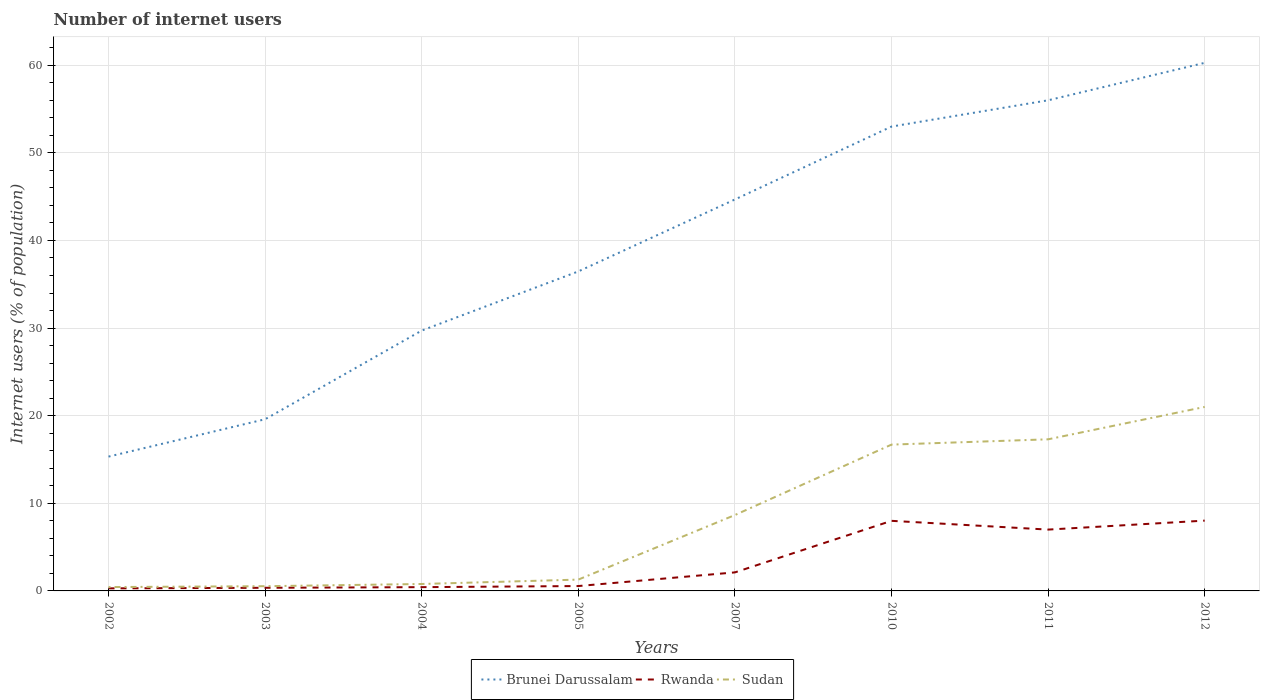How many different coloured lines are there?
Offer a terse response. 3. Does the line corresponding to Brunei Darussalam intersect with the line corresponding to Sudan?
Your response must be concise. No. Across all years, what is the maximum number of internet users in Sudan?
Provide a short and direct response. 0.44. What is the total number of internet users in Rwanda in the graph?
Your response must be concise. -7.64. What is the difference between the highest and the second highest number of internet users in Rwanda?
Provide a succinct answer. 7.73. Is the number of internet users in Brunei Darussalam strictly greater than the number of internet users in Rwanda over the years?
Provide a short and direct response. No. How many years are there in the graph?
Make the answer very short. 8. What is the difference between two consecutive major ticks on the Y-axis?
Your answer should be compact. 10. Does the graph contain any zero values?
Provide a short and direct response. No. Where does the legend appear in the graph?
Your answer should be compact. Bottom center. How many legend labels are there?
Offer a terse response. 3. How are the legend labels stacked?
Offer a very short reply. Horizontal. What is the title of the graph?
Make the answer very short. Number of internet users. What is the label or title of the X-axis?
Your answer should be compact. Years. What is the label or title of the Y-axis?
Give a very brief answer. Internet users (% of population). What is the Internet users (% of population) of Brunei Darussalam in 2002?
Make the answer very short. 15.33. What is the Internet users (% of population) of Rwanda in 2002?
Make the answer very short. 0.29. What is the Internet users (% of population) in Sudan in 2002?
Offer a very short reply. 0.44. What is the Internet users (% of population) of Brunei Darussalam in 2003?
Keep it short and to the point. 19.6. What is the Internet users (% of population) in Rwanda in 2003?
Ensure brevity in your answer.  0.36. What is the Internet users (% of population) of Sudan in 2003?
Your answer should be very brief. 0.54. What is the Internet users (% of population) in Brunei Darussalam in 2004?
Provide a succinct answer. 29.72. What is the Internet users (% of population) of Rwanda in 2004?
Make the answer very short. 0.43. What is the Internet users (% of population) in Sudan in 2004?
Give a very brief answer. 0.79. What is the Internet users (% of population) of Brunei Darussalam in 2005?
Provide a succinct answer. 36.47. What is the Internet users (% of population) of Rwanda in 2005?
Make the answer very short. 0.56. What is the Internet users (% of population) in Sudan in 2005?
Your response must be concise. 1.29. What is the Internet users (% of population) of Brunei Darussalam in 2007?
Offer a terse response. 44.68. What is the Internet users (% of population) of Rwanda in 2007?
Your response must be concise. 2.12. What is the Internet users (% of population) in Sudan in 2007?
Offer a terse response. 8.66. What is the Internet users (% of population) of Brunei Darussalam in 2010?
Keep it short and to the point. 53. What is the Internet users (% of population) in Rwanda in 2011?
Offer a very short reply. 7. What is the Internet users (% of population) of Sudan in 2011?
Provide a succinct answer. 17.3. What is the Internet users (% of population) of Brunei Darussalam in 2012?
Keep it short and to the point. 60.27. What is the Internet users (% of population) in Rwanda in 2012?
Give a very brief answer. 8.02. Across all years, what is the maximum Internet users (% of population) in Brunei Darussalam?
Provide a succinct answer. 60.27. Across all years, what is the maximum Internet users (% of population) in Rwanda?
Offer a terse response. 8.02. Across all years, what is the maximum Internet users (% of population) in Sudan?
Give a very brief answer. 21. Across all years, what is the minimum Internet users (% of population) of Brunei Darussalam?
Offer a very short reply. 15.33. Across all years, what is the minimum Internet users (% of population) of Rwanda?
Make the answer very short. 0.29. Across all years, what is the minimum Internet users (% of population) of Sudan?
Provide a succinct answer. 0.44. What is the total Internet users (% of population) of Brunei Darussalam in the graph?
Offer a very short reply. 315.06. What is the total Internet users (% of population) of Rwanda in the graph?
Your answer should be compact. 26.78. What is the total Internet users (% of population) of Sudan in the graph?
Your answer should be very brief. 66.73. What is the difference between the Internet users (% of population) of Brunei Darussalam in 2002 and that in 2003?
Keep it short and to the point. -4.27. What is the difference between the Internet users (% of population) of Rwanda in 2002 and that in 2003?
Give a very brief answer. -0.06. What is the difference between the Internet users (% of population) of Sudan in 2002 and that in 2003?
Ensure brevity in your answer.  -0.1. What is the difference between the Internet users (% of population) of Brunei Darussalam in 2002 and that in 2004?
Provide a short and direct response. -14.39. What is the difference between the Internet users (% of population) in Rwanda in 2002 and that in 2004?
Provide a short and direct response. -0.14. What is the difference between the Internet users (% of population) in Sudan in 2002 and that in 2004?
Offer a terse response. -0.35. What is the difference between the Internet users (% of population) of Brunei Darussalam in 2002 and that in 2005?
Keep it short and to the point. -21.14. What is the difference between the Internet users (% of population) of Rwanda in 2002 and that in 2005?
Provide a short and direct response. -0.26. What is the difference between the Internet users (% of population) of Sudan in 2002 and that in 2005?
Give a very brief answer. -0.85. What is the difference between the Internet users (% of population) in Brunei Darussalam in 2002 and that in 2007?
Keep it short and to the point. -29.35. What is the difference between the Internet users (% of population) in Rwanda in 2002 and that in 2007?
Offer a very short reply. -1.82. What is the difference between the Internet users (% of population) of Sudan in 2002 and that in 2007?
Make the answer very short. -8.22. What is the difference between the Internet users (% of population) of Brunei Darussalam in 2002 and that in 2010?
Offer a very short reply. -37.67. What is the difference between the Internet users (% of population) of Rwanda in 2002 and that in 2010?
Offer a very short reply. -7.71. What is the difference between the Internet users (% of population) in Sudan in 2002 and that in 2010?
Provide a short and direct response. -16.26. What is the difference between the Internet users (% of population) in Brunei Darussalam in 2002 and that in 2011?
Give a very brief answer. -40.67. What is the difference between the Internet users (% of population) in Rwanda in 2002 and that in 2011?
Your answer should be compact. -6.71. What is the difference between the Internet users (% of population) in Sudan in 2002 and that in 2011?
Make the answer very short. -16.86. What is the difference between the Internet users (% of population) of Brunei Darussalam in 2002 and that in 2012?
Provide a short and direct response. -44.94. What is the difference between the Internet users (% of population) of Rwanda in 2002 and that in 2012?
Your answer should be compact. -7.73. What is the difference between the Internet users (% of population) of Sudan in 2002 and that in 2012?
Make the answer very short. -20.56. What is the difference between the Internet users (% of population) in Brunei Darussalam in 2003 and that in 2004?
Your answer should be very brief. -10.12. What is the difference between the Internet users (% of population) in Rwanda in 2003 and that in 2004?
Keep it short and to the point. -0.07. What is the difference between the Internet users (% of population) in Sudan in 2003 and that in 2004?
Make the answer very short. -0.25. What is the difference between the Internet users (% of population) in Brunei Darussalam in 2003 and that in 2005?
Offer a terse response. -16.87. What is the difference between the Internet users (% of population) of Rwanda in 2003 and that in 2005?
Your response must be concise. -0.2. What is the difference between the Internet users (% of population) in Sudan in 2003 and that in 2005?
Make the answer very short. -0.75. What is the difference between the Internet users (% of population) of Brunei Darussalam in 2003 and that in 2007?
Give a very brief answer. -25.09. What is the difference between the Internet users (% of population) in Rwanda in 2003 and that in 2007?
Give a very brief answer. -1.76. What is the difference between the Internet users (% of population) in Sudan in 2003 and that in 2007?
Keep it short and to the point. -8.12. What is the difference between the Internet users (% of population) of Brunei Darussalam in 2003 and that in 2010?
Provide a short and direct response. -33.41. What is the difference between the Internet users (% of population) in Rwanda in 2003 and that in 2010?
Your answer should be compact. -7.64. What is the difference between the Internet users (% of population) in Sudan in 2003 and that in 2010?
Provide a short and direct response. -16.16. What is the difference between the Internet users (% of population) in Brunei Darussalam in 2003 and that in 2011?
Your response must be concise. -36.41. What is the difference between the Internet users (% of population) of Rwanda in 2003 and that in 2011?
Keep it short and to the point. -6.64. What is the difference between the Internet users (% of population) in Sudan in 2003 and that in 2011?
Ensure brevity in your answer.  -16.77. What is the difference between the Internet users (% of population) of Brunei Darussalam in 2003 and that in 2012?
Your answer should be very brief. -40.68. What is the difference between the Internet users (% of population) of Rwanda in 2003 and that in 2012?
Make the answer very short. -7.67. What is the difference between the Internet users (% of population) in Sudan in 2003 and that in 2012?
Your answer should be very brief. -20.46. What is the difference between the Internet users (% of population) of Brunei Darussalam in 2004 and that in 2005?
Offer a very short reply. -6.75. What is the difference between the Internet users (% of population) in Rwanda in 2004 and that in 2005?
Your answer should be very brief. -0.13. What is the difference between the Internet users (% of population) in Sudan in 2004 and that in 2005?
Offer a terse response. -0.5. What is the difference between the Internet users (% of population) in Brunei Darussalam in 2004 and that in 2007?
Make the answer very short. -14.96. What is the difference between the Internet users (% of population) of Rwanda in 2004 and that in 2007?
Ensure brevity in your answer.  -1.68. What is the difference between the Internet users (% of population) of Sudan in 2004 and that in 2007?
Offer a very short reply. -7.87. What is the difference between the Internet users (% of population) of Brunei Darussalam in 2004 and that in 2010?
Your answer should be compact. -23.28. What is the difference between the Internet users (% of population) in Rwanda in 2004 and that in 2010?
Provide a short and direct response. -7.57. What is the difference between the Internet users (% of population) in Sudan in 2004 and that in 2010?
Your answer should be very brief. -15.91. What is the difference between the Internet users (% of population) of Brunei Darussalam in 2004 and that in 2011?
Provide a short and direct response. -26.28. What is the difference between the Internet users (% of population) in Rwanda in 2004 and that in 2011?
Keep it short and to the point. -6.57. What is the difference between the Internet users (% of population) in Sudan in 2004 and that in 2011?
Ensure brevity in your answer.  -16.51. What is the difference between the Internet users (% of population) of Brunei Darussalam in 2004 and that in 2012?
Make the answer very short. -30.56. What is the difference between the Internet users (% of population) in Rwanda in 2004 and that in 2012?
Make the answer very short. -7.59. What is the difference between the Internet users (% of population) of Sudan in 2004 and that in 2012?
Provide a succinct answer. -20.21. What is the difference between the Internet users (% of population) of Brunei Darussalam in 2005 and that in 2007?
Offer a very short reply. -8.21. What is the difference between the Internet users (% of population) of Rwanda in 2005 and that in 2007?
Keep it short and to the point. -1.56. What is the difference between the Internet users (% of population) in Sudan in 2005 and that in 2007?
Your answer should be compact. -7.37. What is the difference between the Internet users (% of population) of Brunei Darussalam in 2005 and that in 2010?
Offer a very short reply. -16.53. What is the difference between the Internet users (% of population) of Rwanda in 2005 and that in 2010?
Ensure brevity in your answer.  -7.44. What is the difference between the Internet users (% of population) in Sudan in 2005 and that in 2010?
Your answer should be compact. -15.41. What is the difference between the Internet users (% of population) of Brunei Darussalam in 2005 and that in 2011?
Offer a terse response. -19.53. What is the difference between the Internet users (% of population) in Rwanda in 2005 and that in 2011?
Offer a terse response. -6.44. What is the difference between the Internet users (% of population) in Sudan in 2005 and that in 2011?
Your answer should be compact. -16.01. What is the difference between the Internet users (% of population) of Brunei Darussalam in 2005 and that in 2012?
Make the answer very short. -23.81. What is the difference between the Internet users (% of population) in Rwanda in 2005 and that in 2012?
Provide a short and direct response. -7.47. What is the difference between the Internet users (% of population) in Sudan in 2005 and that in 2012?
Ensure brevity in your answer.  -19.71. What is the difference between the Internet users (% of population) in Brunei Darussalam in 2007 and that in 2010?
Offer a terse response. -8.32. What is the difference between the Internet users (% of population) in Rwanda in 2007 and that in 2010?
Provide a succinct answer. -5.88. What is the difference between the Internet users (% of population) in Sudan in 2007 and that in 2010?
Give a very brief answer. -8.04. What is the difference between the Internet users (% of population) of Brunei Darussalam in 2007 and that in 2011?
Your response must be concise. -11.32. What is the difference between the Internet users (% of population) in Rwanda in 2007 and that in 2011?
Keep it short and to the point. -4.88. What is the difference between the Internet users (% of population) of Sudan in 2007 and that in 2011?
Your response must be concise. -8.64. What is the difference between the Internet users (% of population) in Brunei Darussalam in 2007 and that in 2012?
Keep it short and to the point. -15.59. What is the difference between the Internet users (% of population) in Rwanda in 2007 and that in 2012?
Your answer should be compact. -5.91. What is the difference between the Internet users (% of population) of Sudan in 2007 and that in 2012?
Ensure brevity in your answer.  -12.34. What is the difference between the Internet users (% of population) in Brunei Darussalam in 2010 and that in 2011?
Provide a succinct answer. -3. What is the difference between the Internet users (% of population) in Rwanda in 2010 and that in 2011?
Offer a very short reply. 1. What is the difference between the Internet users (% of population) in Sudan in 2010 and that in 2011?
Offer a very short reply. -0.6. What is the difference between the Internet users (% of population) in Brunei Darussalam in 2010 and that in 2012?
Offer a very short reply. -7.27. What is the difference between the Internet users (% of population) in Rwanda in 2010 and that in 2012?
Offer a terse response. -0.02. What is the difference between the Internet users (% of population) of Sudan in 2010 and that in 2012?
Give a very brief answer. -4.3. What is the difference between the Internet users (% of population) in Brunei Darussalam in 2011 and that in 2012?
Your answer should be compact. -4.27. What is the difference between the Internet users (% of population) of Rwanda in 2011 and that in 2012?
Provide a succinct answer. -1.02. What is the difference between the Internet users (% of population) in Sudan in 2011 and that in 2012?
Give a very brief answer. -3.7. What is the difference between the Internet users (% of population) in Brunei Darussalam in 2002 and the Internet users (% of population) in Rwanda in 2003?
Keep it short and to the point. 14.97. What is the difference between the Internet users (% of population) in Brunei Darussalam in 2002 and the Internet users (% of population) in Sudan in 2003?
Offer a terse response. 14.79. What is the difference between the Internet users (% of population) of Rwanda in 2002 and the Internet users (% of population) of Sudan in 2003?
Offer a terse response. -0.25. What is the difference between the Internet users (% of population) of Brunei Darussalam in 2002 and the Internet users (% of population) of Rwanda in 2004?
Provide a short and direct response. 14.9. What is the difference between the Internet users (% of population) in Brunei Darussalam in 2002 and the Internet users (% of population) in Sudan in 2004?
Your answer should be very brief. 14.54. What is the difference between the Internet users (% of population) of Rwanda in 2002 and the Internet users (% of population) of Sudan in 2004?
Ensure brevity in your answer.  -0.5. What is the difference between the Internet users (% of population) in Brunei Darussalam in 2002 and the Internet users (% of population) in Rwanda in 2005?
Offer a very short reply. 14.77. What is the difference between the Internet users (% of population) of Brunei Darussalam in 2002 and the Internet users (% of population) of Sudan in 2005?
Make the answer very short. 14.04. What is the difference between the Internet users (% of population) of Rwanda in 2002 and the Internet users (% of population) of Sudan in 2005?
Offer a terse response. -1. What is the difference between the Internet users (% of population) of Brunei Darussalam in 2002 and the Internet users (% of population) of Rwanda in 2007?
Provide a succinct answer. 13.21. What is the difference between the Internet users (% of population) in Brunei Darussalam in 2002 and the Internet users (% of population) in Sudan in 2007?
Offer a terse response. 6.67. What is the difference between the Internet users (% of population) in Rwanda in 2002 and the Internet users (% of population) in Sudan in 2007?
Your response must be concise. -8.37. What is the difference between the Internet users (% of population) in Brunei Darussalam in 2002 and the Internet users (% of population) in Rwanda in 2010?
Make the answer very short. 7.33. What is the difference between the Internet users (% of population) of Brunei Darussalam in 2002 and the Internet users (% of population) of Sudan in 2010?
Your response must be concise. -1.37. What is the difference between the Internet users (% of population) of Rwanda in 2002 and the Internet users (% of population) of Sudan in 2010?
Offer a very short reply. -16.41. What is the difference between the Internet users (% of population) in Brunei Darussalam in 2002 and the Internet users (% of population) in Rwanda in 2011?
Give a very brief answer. 8.33. What is the difference between the Internet users (% of population) in Brunei Darussalam in 2002 and the Internet users (% of population) in Sudan in 2011?
Provide a short and direct response. -1.97. What is the difference between the Internet users (% of population) of Rwanda in 2002 and the Internet users (% of population) of Sudan in 2011?
Offer a very short reply. -17.01. What is the difference between the Internet users (% of population) of Brunei Darussalam in 2002 and the Internet users (% of population) of Rwanda in 2012?
Give a very brief answer. 7.31. What is the difference between the Internet users (% of population) in Brunei Darussalam in 2002 and the Internet users (% of population) in Sudan in 2012?
Ensure brevity in your answer.  -5.67. What is the difference between the Internet users (% of population) of Rwanda in 2002 and the Internet users (% of population) of Sudan in 2012?
Your response must be concise. -20.71. What is the difference between the Internet users (% of population) in Brunei Darussalam in 2003 and the Internet users (% of population) in Rwanda in 2004?
Your response must be concise. 19.16. What is the difference between the Internet users (% of population) in Brunei Darussalam in 2003 and the Internet users (% of population) in Sudan in 2004?
Ensure brevity in your answer.  18.8. What is the difference between the Internet users (% of population) of Rwanda in 2003 and the Internet users (% of population) of Sudan in 2004?
Your answer should be compact. -0.43. What is the difference between the Internet users (% of population) in Brunei Darussalam in 2003 and the Internet users (% of population) in Rwanda in 2005?
Provide a succinct answer. 19.04. What is the difference between the Internet users (% of population) of Brunei Darussalam in 2003 and the Internet users (% of population) of Sudan in 2005?
Your response must be concise. 18.3. What is the difference between the Internet users (% of population) of Rwanda in 2003 and the Internet users (% of population) of Sudan in 2005?
Provide a short and direct response. -0.94. What is the difference between the Internet users (% of population) in Brunei Darussalam in 2003 and the Internet users (% of population) in Rwanda in 2007?
Your response must be concise. 17.48. What is the difference between the Internet users (% of population) of Brunei Darussalam in 2003 and the Internet users (% of population) of Sudan in 2007?
Your response must be concise. 10.94. What is the difference between the Internet users (% of population) in Rwanda in 2003 and the Internet users (% of population) in Sudan in 2007?
Keep it short and to the point. -8.3. What is the difference between the Internet users (% of population) of Brunei Darussalam in 2003 and the Internet users (% of population) of Rwanda in 2010?
Ensure brevity in your answer.  11.6. What is the difference between the Internet users (% of population) of Brunei Darussalam in 2003 and the Internet users (% of population) of Sudan in 2010?
Make the answer very short. 2.9. What is the difference between the Internet users (% of population) in Rwanda in 2003 and the Internet users (% of population) in Sudan in 2010?
Your answer should be compact. -16.34. What is the difference between the Internet users (% of population) of Brunei Darussalam in 2003 and the Internet users (% of population) of Rwanda in 2011?
Keep it short and to the point. 12.6. What is the difference between the Internet users (% of population) in Brunei Darussalam in 2003 and the Internet users (% of population) in Sudan in 2011?
Make the answer very short. 2.29. What is the difference between the Internet users (% of population) of Rwanda in 2003 and the Internet users (% of population) of Sudan in 2011?
Make the answer very short. -16.95. What is the difference between the Internet users (% of population) of Brunei Darussalam in 2003 and the Internet users (% of population) of Rwanda in 2012?
Offer a terse response. 11.57. What is the difference between the Internet users (% of population) in Brunei Darussalam in 2003 and the Internet users (% of population) in Sudan in 2012?
Provide a short and direct response. -1.41. What is the difference between the Internet users (% of population) of Rwanda in 2003 and the Internet users (% of population) of Sudan in 2012?
Give a very brief answer. -20.64. What is the difference between the Internet users (% of population) of Brunei Darussalam in 2004 and the Internet users (% of population) of Rwanda in 2005?
Your answer should be compact. 29.16. What is the difference between the Internet users (% of population) of Brunei Darussalam in 2004 and the Internet users (% of population) of Sudan in 2005?
Provide a succinct answer. 28.42. What is the difference between the Internet users (% of population) in Rwanda in 2004 and the Internet users (% of population) in Sudan in 2005?
Offer a terse response. -0.86. What is the difference between the Internet users (% of population) of Brunei Darussalam in 2004 and the Internet users (% of population) of Rwanda in 2007?
Provide a succinct answer. 27.6. What is the difference between the Internet users (% of population) of Brunei Darussalam in 2004 and the Internet users (% of population) of Sudan in 2007?
Your answer should be very brief. 21.06. What is the difference between the Internet users (% of population) of Rwanda in 2004 and the Internet users (% of population) of Sudan in 2007?
Offer a terse response. -8.23. What is the difference between the Internet users (% of population) in Brunei Darussalam in 2004 and the Internet users (% of population) in Rwanda in 2010?
Ensure brevity in your answer.  21.72. What is the difference between the Internet users (% of population) in Brunei Darussalam in 2004 and the Internet users (% of population) in Sudan in 2010?
Offer a terse response. 13.02. What is the difference between the Internet users (% of population) in Rwanda in 2004 and the Internet users (% of population) in Sudan in 2010?
Your response must be concise. -16.27. What is the difference between the Internet users (% of population) in Brunei Darussalam in 2004 and the Internet users (% of population) in Rwanda in 2011?
Offer a terse response. 22.72. What is the difference between the Internet users (% of population) of Brunei Darussalam in 2004 and the Internet users (% of population) of Sudan in 2011?
Keep it short and to the point. 12.41. What is the difference between the Internet users (% of population) of Rwanda in 2004 and the Internet users (% of population) of Sudan in 2011?
Your answer should be compact. -16.87. What is the difference between the Internet users (% of population) of Brunei Darussalam in 2004 and the Internet users (% of population) of Rwanda in 2012?
Offer a very short reply. 21.69. What is the difference between the Internet users (% of population) in Brunei Darussalam in 2004 and the Internet users (% of population) in Sudan in 2012?
Offer a terse response. 8.72. What is the difference between the Internet users (% of population) in Rwanda in 2004 and the Internet users (% of population) in Sudan in 2012?
Ensure brevity in your answer.  -20.57. What is the difference between the Internet users (% of population) in Brunei Darussalam in 2005 and the Internet users (% of population) in Rwanda in 2007?
Your answer should be very brief. 34.35. What is the difference between the Internet users (% of population) in Brunei Darussalam in 2005 and the Internet users (% of population) in Sudan in 2007?
Keep it short and to the point. 27.81. What is the difference between the Internet users (% of population) of Rwanda in 2005 and the Internet users (% of population) of Sudan in 2007?
Your answer should be compact. -8.1. What is the difference between the Internet users (% of population) of Brunei Darussalam in 2005 and the Internet users (% of population) of Rwanda in 2010?
Provide a short and direct response. 28.47. What is the difference between the Internet users (% of population) in Brunei Darussalam in 2005 and the Internet users (% of population) in Sudan in 2010?
Provide a succinct answer. 19.77. What is the difference between the Internet users (% of population) of Rwanda in 2005 and the Internet users (% of population) of Sudan in 2010?
Keep it short and to the point. -16.14. What is the difference between the Internet users (% of population) in Brunei Darussalam in 2005 and the Internet users (% of population) in Rwanda in 2011?
Give a very brief answer. 29.47. What is the difference between the Internet users (% of population) in Brunei Darussalam in 2005 and the Internet users (% of population) in Sudan in 2011?
Offer a terse response. 19.16. What is the difference between the Internet users (% of population) in Rwanda in 2005 and the Internet users (% of population) in Sudan in 2011?
Your response must be concise. -16.75. What is the difference between the Internet users (% of population) of Brunei Darussalam in 2005 and the Internet users (% of population) of Rwanda in 2012?
Give a very brief answer. 28.44. What is the difference between the Internet users (% of population) in Brunei Darussalam in 2005 and the Internet users (% of population) in Sudan in 2012?
Make the answer very short. 15.47. What is the difference between the Internet users (% of population) of Rwanda in 2005 and the Internet users (% of population) of Sudan in 2012?
Provide a short and direct response. -20.44. What is the difference between the Internet users (% of population) in Brunei Darussalam in 2007 and the Internet users (% of population) in Rwanda in 2010?
Your response must be concise. 36.68. What is the difference between the Internet users (% of population) of Brunei Darussalam in 2007 and the Internet users (% of population) of Sudan in 2010?
Give a very brief answer. 27.98. What is the difference between the Internet users (% of population) in Rwanda in 2007 and the Internet users (% of population) in Sudan in 2010?
Ensure brevity in your answer.  -14.58. What is the difference between the Internet users (% of population) of Brunei Darussalam in 2007 and the Internet users (% of population) of Rwanda in 2011?
Provide a succinct answer. 37.68. What is the difference between the Internet users (% of population) of Brunei Darussalam in 2007 and the Internet users (% of population) of Sudan in 2011?
Offer a very short reply. 27.38. What is the difference between the Internet users (% of population) of Rwanda in 2007 and the Internet users (% of population) of Sudan in 2011?
Provide a short and direct response. -15.19. What is the difference between the Internet users (% of population) in Brunei Darussalam in 2007 and the Internet users (% of population) in Rwanda in 2012?
Your answer should be compact. 36.66. What is the difference between the Internet users (% of population) in Brunei Darussalam in 2007 and the Internet users (% of population) in Sudan in 2012?
Provide a succinct answer. 23.68. What is the difference between the Internet users (% of population) in Rwanda in 2007 and the Internet users (% of population) in Sudan in 2012?
Your answer should be very brief. -18.88. What is the difference between the Internet users (% of population) in Brunei Darussalam in 2010 and the Internet users (% of population) in Sudan in 2011?
Make the answer very short. 35.7. What is the difference between the Internet users (% of population) in Rwanda in 2010 and the Internet users (% of population) in Sudan in 2011?
Keep it short and to the point. -9.3. What is the difference between the Internet users (% of population) in Brunei Darussalam in 2010 and the Internet users (% of population) in Rwanda in 2012?
Give a very brief answer. 44.98. What is the difference between the Internet users (% of population) in Rwanda in 2010 and the Internet users (% of population) in Sudan in 2012?
Your response must be concise. -13. What is the difference between the Internet users (% of population) in Brunei Darussalam in 2011 and the Internet users (% of population) in Rwanda in 2012?
Your response must be concise. 47.98. What is the difference between the Internet users (% of population) in Brunei Darussalam in 2011 and the Internet users (% of population) in Sudan in 2012?
Provide a short and direct response. 35. What is the difference between the Internet users (% of population) of Rwanda in 2011 and the Internet users (% of population) of Sudan in 2012?
Keep it short and to the point. -14. What is the average Internet users (% of population) in Brunei Darussalam per year?
Offer a terse response. 39.38. What is the average Internet users (% of population) in Rwanda per year?
Your answer should be very brief. 3.35. What is the average Internet users (% of population) of Sudan per year?
Your answer should be compact. 8.34. In the year 2002, what is the difference between the Internet users (% of population) in Brunei Darussalam and Internet users (% of population) in Rwanda?
Offer a very short reply. 15.04. In the year 2002, what is the difference between the Internet users (% of population) of Brunei Darussalam and Internet users (% of population) of Sudan?
Your answer should be compact. 14.89. In the year 2002, what is the difference between the Internet users (% of population) of Rwanda and Internet users (% of population) of Sudan?
Ensure brevity in your answer.  -0.15. In the year 2003, what is the difference between the Internet users (% of population) in Brunei Darussalam and Internet users (% of population) in Rwanda?
Give a very brief answer. 19.24. In the year 2003, what is the difference between the Internet users (% of population) of Brunei Darussalam and Internet users (% of population) of Sudan?
Give a very brief answer. 19.06. In the year 2003, what is the difference between the Internet users (% of population) in Rwanda and Internet users (% of population) in Sudan?
Your answer should be compact. -0.18. In the year 2004, what is the difference between the Internet users (% of population) in Brunei Darussalam and Internet users (% of population) in Rwanda?
Give a very brief answer. 29.28. In the year 2004, what is the difference between the Internet users (% of population) of Brunei Darussalam and Internet users (% of population) of Sudan?
Offer a terse response. 28.92. In the year 2004, what is the difference between the Internet users (% of population) of Rwanda and Internet users (% of population) of Sudan?
Provide a short and direct response. -0.36. In the year 2005, what is the difference between the Internet users (% of population) in Brunei Darussalam and Internet users (% of population) in Rwanda?
Provide a short and direct response. 35.91. In the year 2005, what is the difference between the Internet users (% of population) in Brunei Darussalam and Internet users (% of population) in Sudan?
Offer a very short reply. 35.17. In the year 2005, what is the difference between the Internet users (% of population) of Rwanda and Internet users (% of population) of Sudan?
Provide a short and direct response. -0.74. In the year 2007, what is the difference between the Internet users (% of population) of Brunei Darussalam and Internet users (% of population) of Rwanda?
Your answer should be very brief. 42.56. In the year 2007, what is the difference between the Internet users (% of population) in Brunei Darussalam and Internet users (% of population) in Sudan?
Your response must be concise. 36.02. In the year 2007, what is the difference between the Internet users (% of population) in Rwanda and Internet users (% of population) in Sudan?
Keep it short and to the point. -6.54. In the year 2010, what is the difference between the Internet users (% of population) in Brunei Darussalam and Internet users (% of population) in Rwanda?
Your answer should be very brief. 45. In the year 2010, what is the difference between the Internet users (% of population) of Brunei Darussalam and Internet users (% of population) of Sudan?
Make the answer very short. 36.3. In the year 2011, what is the difference between the Internet users (% of population) of Brunei Darussalam and Internet users (% of population) of Sudan?
Your answer should be compact. 38.7. In the year 2011, what is the difference between the Internet users (% of population) in Rwanda and Internet users (% of population) in Sudan?
Your answer should be compact. -10.3. In the year 2012, what is the difference between the Internet users (% of population) of Brunei Darussalam and Internet users (% of population) of Rwanda?
Offer a terse response. 52.25. In the year 2012, what is the difference between the Internet users (% of population) in Brunei Darussalam and Internet users (% of population) in Sudan?
Your answer should be very brief. 39.27. In the year 2012, what is the difference between the Internet users (% of population) in Rwanda and Internet users (% of population) in Sudan?
Give a very brief answer. -12.98. What is the ratio of the Internet users (% of population) of Brunei Darussalam in 2002 to that in 2003?
Provide a succinct answer. 0.78. What is the ratio of the Internet users (% of population) of Rwanda in 2002 to that in 2003?
Your response must be concise. 0.82. What is the ratio of the Internet users (% of population) in Sudan in 2002 to that in 2003?
Your answer should be compact. 0.82. What is the ratio of the Internet users (% of population) of Brunei Darussalam in 2002 to that in 2004?
Provide a succinct answer. 0.52. What is the ratio of the Internet users (% of population) of Rwanda in 2002 to that in 2004?
Provide a succinct answer. 0.68. What is the ratio of the Internet users (% of population) of Sudan in 2002 to that in 2004?
Ensure brevity in your answer.  0.56. What is the ratio of the Internet users (% of population) of Brunei Darussalam in 2002 to that in 2005?
Make the answer very short. 0.42. What is the ratio of the Internet users (% of population) of Rwanda in 2002 to that in 2005?
Offer a terse response. 0.53. What is the ratio of the Internet users (% of population) of Sudan in 2002 to that in 2005?
Offer a very short reply. 0.34. What is the ratio of the Internet users (% of population) of Brunei Darussalam in 2002 to that in 2007?
Offer a very short reply. 0.34. What is the ratio of the Internet users (% of population) in Rwanda in 2002 to that in 2007?
Provide a short and direct response. 0.14. What is the ratio of the Internet users (% of population) in Sudan in 2002 to that in 2007?
Your answer should be very brief. 0.05. What is the ratio of the Internet users (% of population) of Brunei Darussalam in 2002 to that in 2010?
Provide a short and direct response. 0.29. What is the ratio of the Internet users (% of population) of Rwanda in 2002 to that in 2010?
Your answer should be very brief. 0.04. What is the ratio of the Internet users (% of population) of Sudan in 2002 to that in 2010?
Offer a terse response. 0.03. What is the ratio of the Internet users (% of population) of Brunei Darussalam in 2002 to that in 2011?
Your answer should be compact. 0.27. What is the ratio of the Internet users (% of population) in Rwanda in 2002 to that in 2011?
Keep it short and to the point. 0.04. What is the ratio of the Internet users (% of population) in Sudan in 2002 to that in 2011?
Offer a terse response. 0.03. What is the ratio of the Internet users (% of population) in Brunei Darussalam in 2002 to that in 2012?
Your response must be concise. 0.25. What is the ratio of the Internet users (% of population) in Rwanda in 2002 to that in 2012?
Make the answer very short. 0.04. What is the ratio of the Internet users (% of population) of Sudan in 2002 to that in 2012?
Your answer should be compact. 0.02. What is the ratio of the Internet users (% of population) of Brunei Darussalam in 2003 to that in 2004?
Make the answer very short. 0.66. What is the ratio of the Internet users (% of population) in Rwanda in 2003 to that in 2004?
Your response must be concise. 0.83. What is the ratio of the Internet users (% of population) in Sudan in 2003 to that in 2004?
Offer a very short reply. 0.68. What is the ratio of the Internet users (% of population) in Brunei Darussalam in 2003 to that in 2005?
Provide a succinct answer. 0.54. What is the ratio of the Internet users (% of population) of Rwanda in 2003 to that in 2005?
Keep it short and to the point. 0.64. What is the ratio of the Internet users (% of population) of Sudan in 2003 to that in 2005?
Provide a succinct answer. 0.42. What is the ratio of the Internet users (% of population) of Brunei Darussalam in 2003 to that in 2007?
Provide a succinct answer. 0.44. What is the ratio of the Internet users (% of population) in Rwanda in 2003 to that in 2007?
Provide a short and direct response. 0.17. What is the ratio of the Internet users (% of population) of Sudan in 2003 to that in 2007?
Make the answer very short. 0.06. What is the ratio of the Internet users (% of population) of Brunei Darussalam in 2003 to that in 2010?
Keep it short and to the point. 0.37. What is the ratio of the Internet users (% of population) in Rwanda in 2003 to that in 2010?
Your response must be concise. 0.04. What is the ratio of the Internet users (% of population) in Sudan in 2003 to that in 2010?
Make the answer very short. 0.03. What is the ratio of the Internet users (% of population) in Brunei Darussalam in 2003 to that in 2011?
Provide a succinct answer. 0.35. What is the ratio of the Internet users (% of population) of Rwanda in 2003 to that in 2011?
Give a very brief answer. 0.05. What is the ratio of the Internet users (% of population) in Sudan in 2003 to that in 2011?
Ensure brevity in your answer.  0.03. What is the ratio of the Internet users (% of population) in Brunei Darussalam in 2003 to that in 2012?
Offer a terse response. 0.33. What is the ratio of the Internet users (% of population) of Rwanda in 2003 to that in 2012?
Provide a succinct answer. 0.04. What is the ratio of the Internet users (% of population) in Sudan in 2003 to that in 2012?
Offer a very short reply. 0.03. What is the ratio of the Internet users (% of population) of Brunei Darussalam in 2004 to that in 2005?
Your response must be concise. 0.81. What is the ratio of the Internet users (% of population) in Rwanda in 2004 to that in 2005?
Give a very brief answer. 0.77. What is the ratio of the Internet users (% of population) in Sudan in 2004 to that in 2005?
Give a very brief answer. 0.61. What is the ratio of the Internet users (% of population) in Brunei Darussalam in 2004 to that in 2007?
Your answer should be very brief. 0.67. What is the ratio of the Internet users (% of population) in Rwanda in 2004 to that in 2007?
Offer a terse response. 0.2. What is the ratio of the Internet users (% of population) in Sudan in 2004 to that in 2007?
Offer a very short reply. 0.09. What is the ratio of the Internet users (% of population) in Brunei Darussalam in 2004 to that in 2010?
Provide a short and direct response. 0.56. What is the ratio of the Internet users (% of population) in Rwanda in 2004 to that in 2010?
Keep it short and to the point. 0.05. What is the ratio of the Internet users (% of population) in Sudan in 2004 to that in 2010?
Offer a terse response. 0.05. What is the ratio of the Internet users (% of population) of Brunei Darussalam in 2004 to that in 2011?
Your response must be concise. 0.53. What is the ratio of the Internet users (% of population) in Rwanda in 2004 to that in 2011?
Keep it short and to the point. 0.06. What is the ratio of the Internet users (% of population) of Sudan in 2004 to that in 2011?
Provide a short and direct response. 0.05. What is the ratio of the Internet users (% of population) of Brunei Darussalam in 2004 to that in 2012?
Keep it short and to the point. 0.49. What is the ratio of the Internet users (% of population) in Rwanda in 2004 to that in 2012?
Offer a very short reply. 0.05. What is the ratio of the Internet users (% of population) in Sudan in 2004 to that in 2012?
Offer a very short reply. 0.04. What is the ratio of the Internet users (% of population) in Brunei Darussalam in 2005 to that in 2007?
Provide a succinct answer. 0.82. What is the ratio of the Internet users (% of population) of Rwanda in 2005 to that in 2007?
Offer a terse response. 0.26. What is the ratio of the Internet users (% of population) in Sudan in 2005 to that in 2007?
Your response must be concise. 0.15. What is the ratio of the Internet users (% of population) of Brunei Darussalam in 2005 to that in 2010?
Provide a short and direct response. 0.69. What is the ratio of the Internet users (% of population) of Rwanda in 2005 to that in 2010?
Your response must be concise. 0.07. What is the ratio of the Internet users (% of population) in Sudan in 2005 to that in 2010?
Give a very brief answer. 0.08. What is the ratio of the Internet users (% of population) of Brunei Darussalam in 2005 to that in 2011?
Offer a very short reply. 0.65. What is the ratio of the Internet users (% of population) in Rwanda in 2005 to that in 2011?
Provide a succinct answer. 0.08. What is the ratio of the Internet users (% of population) in Sudan in 2005 to that in 2011?
Offer a very short reply. 0.07. What is the ratio of the Internet users (% of population) of Brunei Darussalam in 2005 to that in 2012?
Your answer should be very brief. 0.6. What is the ratio of the Internet users (% of population) of Rwanda in 2005 to that in 2012?
Your response must be concise. 0.07. What is the ratio of the Internet users (% of population) of Sudan in 2005 to that in 2012?
Offer a terse response. 0.06. What is the ratio of the Internet users (% of population) in Brunei Darussalam in 2007 to that in 2010?
Make the answer very short. 0.84. What is the ratio of the Internet users (% of population) of Rwanda in 2007 to that in 2010?
Give a very brief answer. 0.26. What is the ratio of the Internet users (% of population) in Sudan in 2007 to that in 2010?
Offer a very short reply. 0.52. What is the ratio of the Internet users (% of population) of Brunei Darussalam in 2007 to that in 2011?
Ensure brevity in your answer.  0.8. What is the ratio of the Internet users (% of population) in Rwanda in 2007 to that in 2011?
Offer a terse response. 0.3. What is the ratio of the Internet users (% of population) of Sudan in 2007 to that in 2011?
Offer a terse response. 0.5. What is the ratio of the Internet users (% of population) of Brunei Darussalam in 2007 to that in 2012?
Your answer should be compact. 0.74. What is the ratio of the Internet users (% of population) of Rwanda in 2007 to that in 2012?
Keep it short and to the point. 0.26. What is the ratio of the Internet users (% of population) of Sudan in 2007 to that in 2012?
Make the answer very short. 0.41. What is the ratio of the Internet users (% of population) in Brunei Darussalam in 2010 to that in 2011?
Offer a very short reply. 0.95. What is the ratio of the Internet users (% of population) in Sudan in 2010 to that in 2011?
Make the answer very short. 0.97. What is the ratio of the Internet users (% of population) in Brunei Darussalam in 2010 to that in 2012?
Provide a short and direct response. 0.88. What is the ratio of the Internet users (% of population) of Sudan in 2010 to that in 2012?
Ensure brevity in your answer.  0.8. What is the ratio of the Internet users (% of population) of Brunei Darussalam in 2011 to that in 2012?
Give a very brief answer. 0.93. What is the ratio of the Internet users (% of population) of Rwanda in 2011 to that in 2012?
Ensure brevity in your answer.  0.87. What is the ratio of the Internet users (% of population) in Sudan in 2011 to that in 2012?
Your response must be concise. 0.82. What is the difference between the highest and the second highest Internet users (% of population) of Brunei Darussalam?
Your answer should be compact. 4.27. What is the difference between the highest and the second highest Internet users (% of population) in Rwanda?
Offer a very short reply. 0.02. What is the difference between the highest and the second highest Internet users (% of population) in Sudan?
Your response must be concise. 3.7. What is the difference between the highest and the lowest Internet users (% of population) in Brunei Darussalam?
Provide a succinct answer. 44.94. What is the difference between the highest and the lowest Internet users (% of population) in Rwanda?
Ensure brevity in your answer.  7.73. What is the difference between the highest and the lowest Internet users (% of population) of Sudan?
Provide a short and direct response. 20.56. 